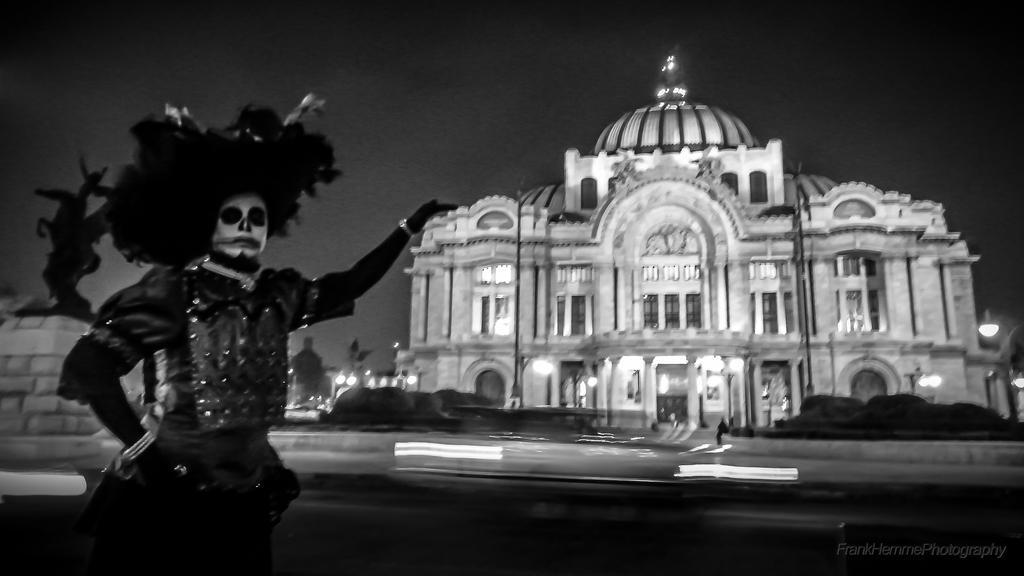Describe this image in one or two sentences. In this picture I can see a building and a human wearing costumes and standing. I can see a statue on the left side and I can see trees, plants, few lights and couple of poles. 